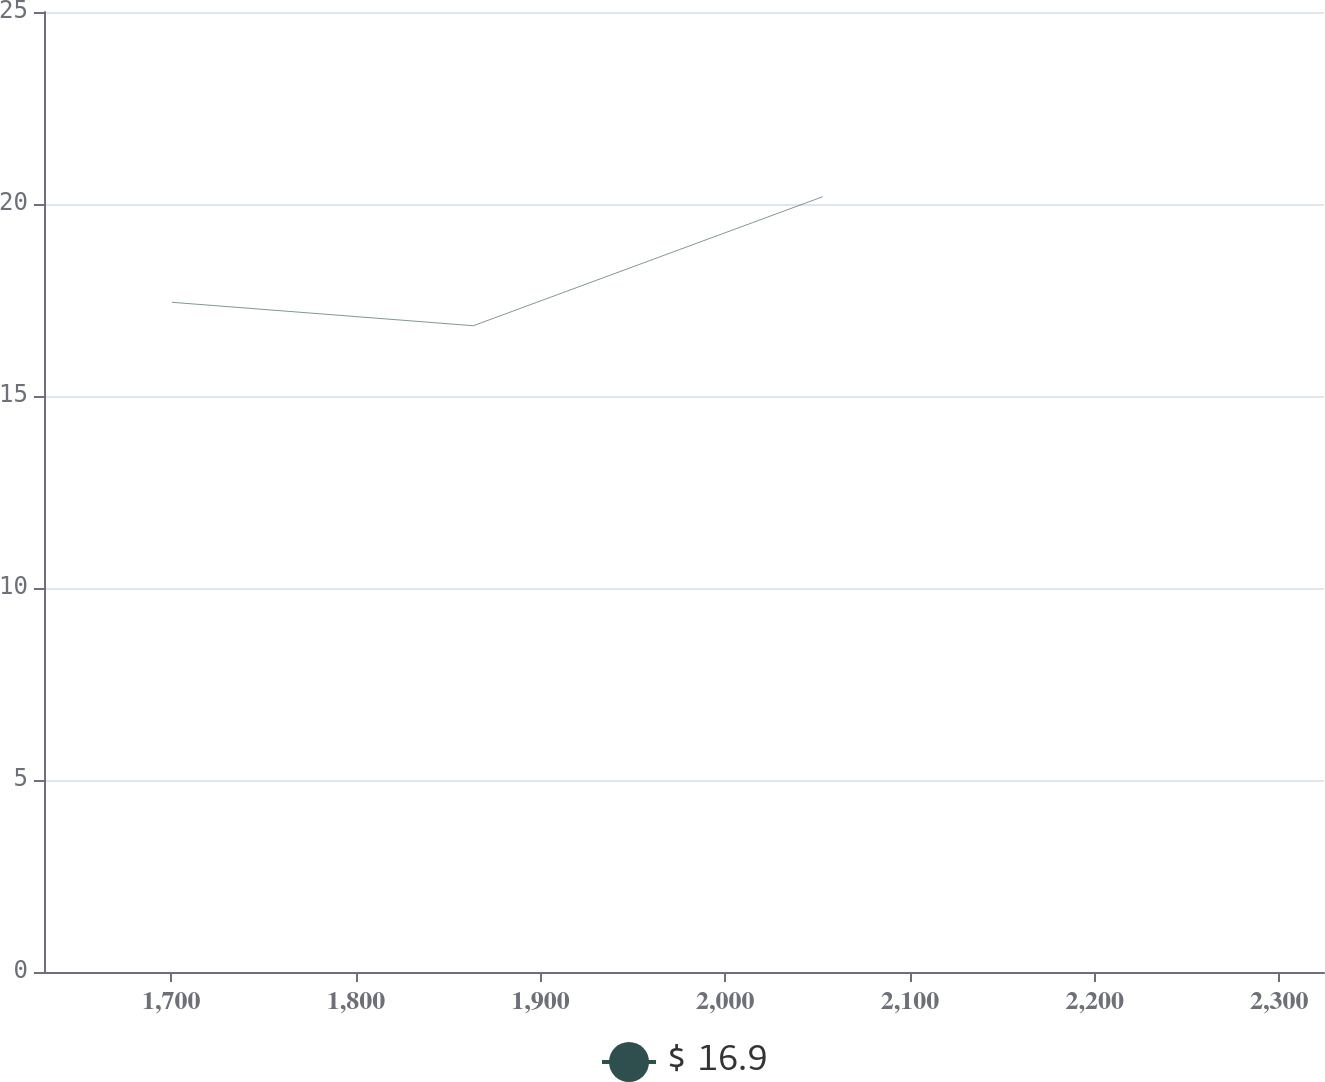<chart> <loc_0><loc_0><loc_500><loc_500><line_chart><ecel><fcel>$ 16.9<nl><fcel>1700.41<fcel>17.44<nl><fcel>1863.59<fcel>16.83<nl><fcel>2052.77<fcel>20.19<nl><fcel>2393.51<fcel>22.95<nl></chart> 